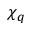Convert formula to latex. <formula><loc_0><loc_0><loc_500><loc_500>\chi _ { q }</formula> 